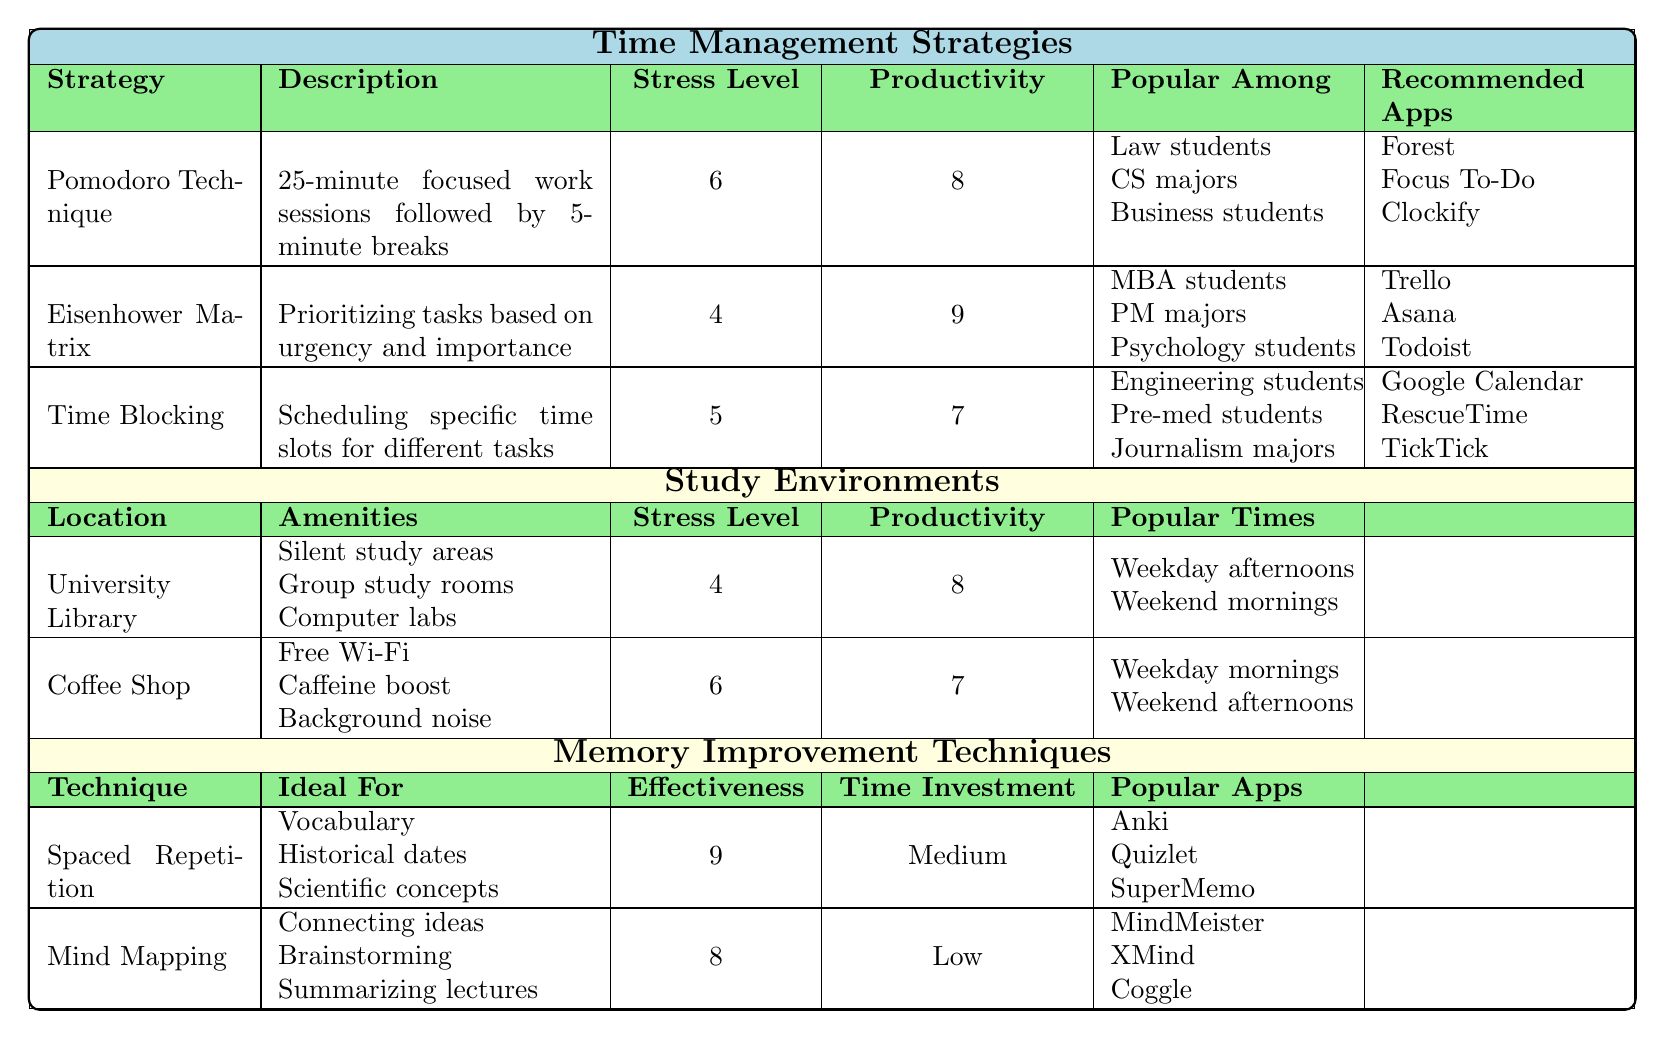What is the average stress level of the "Getting Things Done" strategy? The stress level for the "Getting Things Done" strategy is 3. Since there's only one value for this strategy, the average is 3.
Answer: 3 Which time management strategy has the highest productivity score? The "Eisenhower Matrix" has the highest productivity score of 9.
Answer: 9 What are the popular apps recommended for the "Time Blocking" strategy? For the "Time Blocking" strategy, the recommended apps are Google Calendar, RescueTime, and TickTick.
Answer: Google Calendar, RescueTime, TickTick Is the stress level of studying in a coffee shop greater than that of studying in the university library? The average stress level in the coffee shop is 6, while in the library it is 4. Therefore, yes, the coffee shop has a higher stress level.
Answer: Yes How many study environments have an average stress level lower than 5? Only one study environment, the "University Library," has an average stress level lower than 5 (it has a score of 4).
Answer: 1 What is the productivity difference between the "Pomodoro Technique" and the "Getting Things Done" strategy? The Pomodoro Technique has a productivity score of 8 while Getting Things Done has a score of 8. The difference is 8 - 8 = 0.
Answer: 0 Which study environment has the highest average productivity score? The "University Library" has the highest average productivity score of 8.
Answer: 8 What effectiveness score does "Mnemonic Devices" have? The effectiveness score for Mnemonic Devices is 7, as stated in the table.
Answer: 7 How does the stress level of "Eat That Frog" compare to "Eisenhower Matrix"? "Eat That Frog" has a stress level of 7, while "Eisenhower Matrix" has a stress level of 4. So, Eat That Frog has a higher stress level.
Answer: Higher What is the average effectiveness score for the memory improvement techniques listed? The scores for the techniques are 9, 8, and 7. The average is (9 + 8 + 7) / 3 = 8.
Answer: 8 